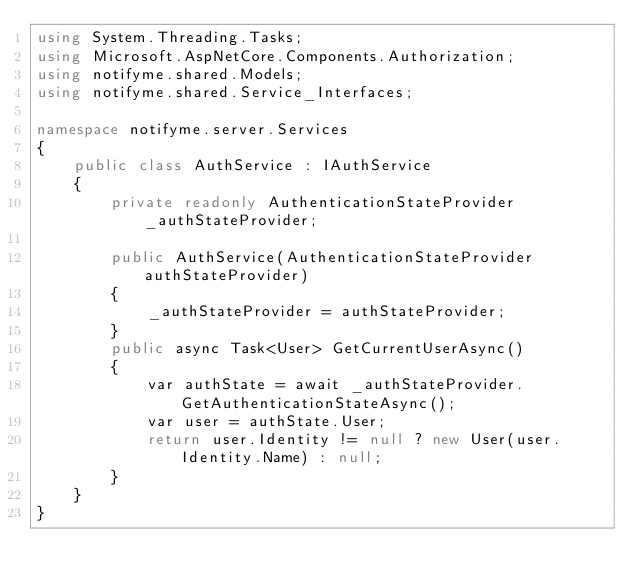Convert code to text. <code><loc_0><loc_0><loc_500><loc_500><_C#_>using System.Threading.Tasks;
using Microsoft.AspNetCore.Components.Authorization;
using notifyme.shared.Models;
using notifyme.shared.Service_Interfaces;

namespace notifyme.server.Services
{
    public class AuthService : IAuthService
    {
        private readonly AuthenticationStateProvider _authStateProvider;

        public AuthService(AuthenticationStateProvider authStateProvider)
        {
            _authStateProvider = authStateProvider;
        }
        public async Task<User> GetCurrentUserAsync()
        {
            var authState = await _authStateProvider.GetAuthenticationStateAsync();
            var user = authState.User;
            return user.Identity != null ? new User(user.Identity.Name) : null;
        }
    }
}</code> 